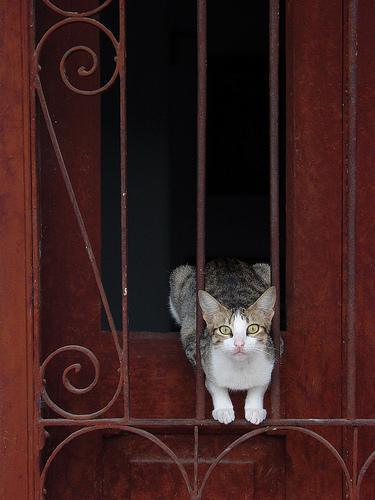How many animals are visible in the picture?
Give a very brief answer. 1. How many windows are visible in the photo?
Give a very brief answer. 1. 